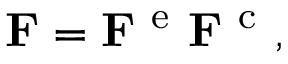Convert formula to latex. <formula><loc_0><loc_0><loc_500><loc_500>{ F } = { F } ^ { e } { F } ^ { c } ,</formula> 